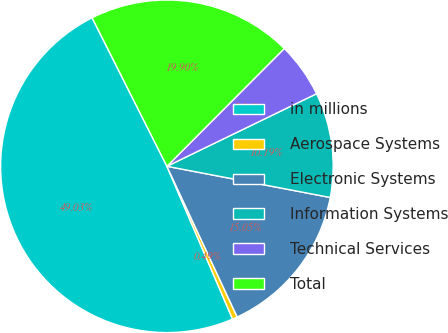Convert chart. <chart><loc_0><loc_0><loc_500><loc_500><pie_chart><fcel>in millions<fcel>Aerospace Systems<fcel>Electronic Systems<fcel>Information Systems<fcel>Technical Services<fcel>Total<nl><fcel>49.03%<fcel>0.49%<fcel>15.05%<fcel>10.19%<fcel>5.34%<fcel>19.9%<nl></chart> 